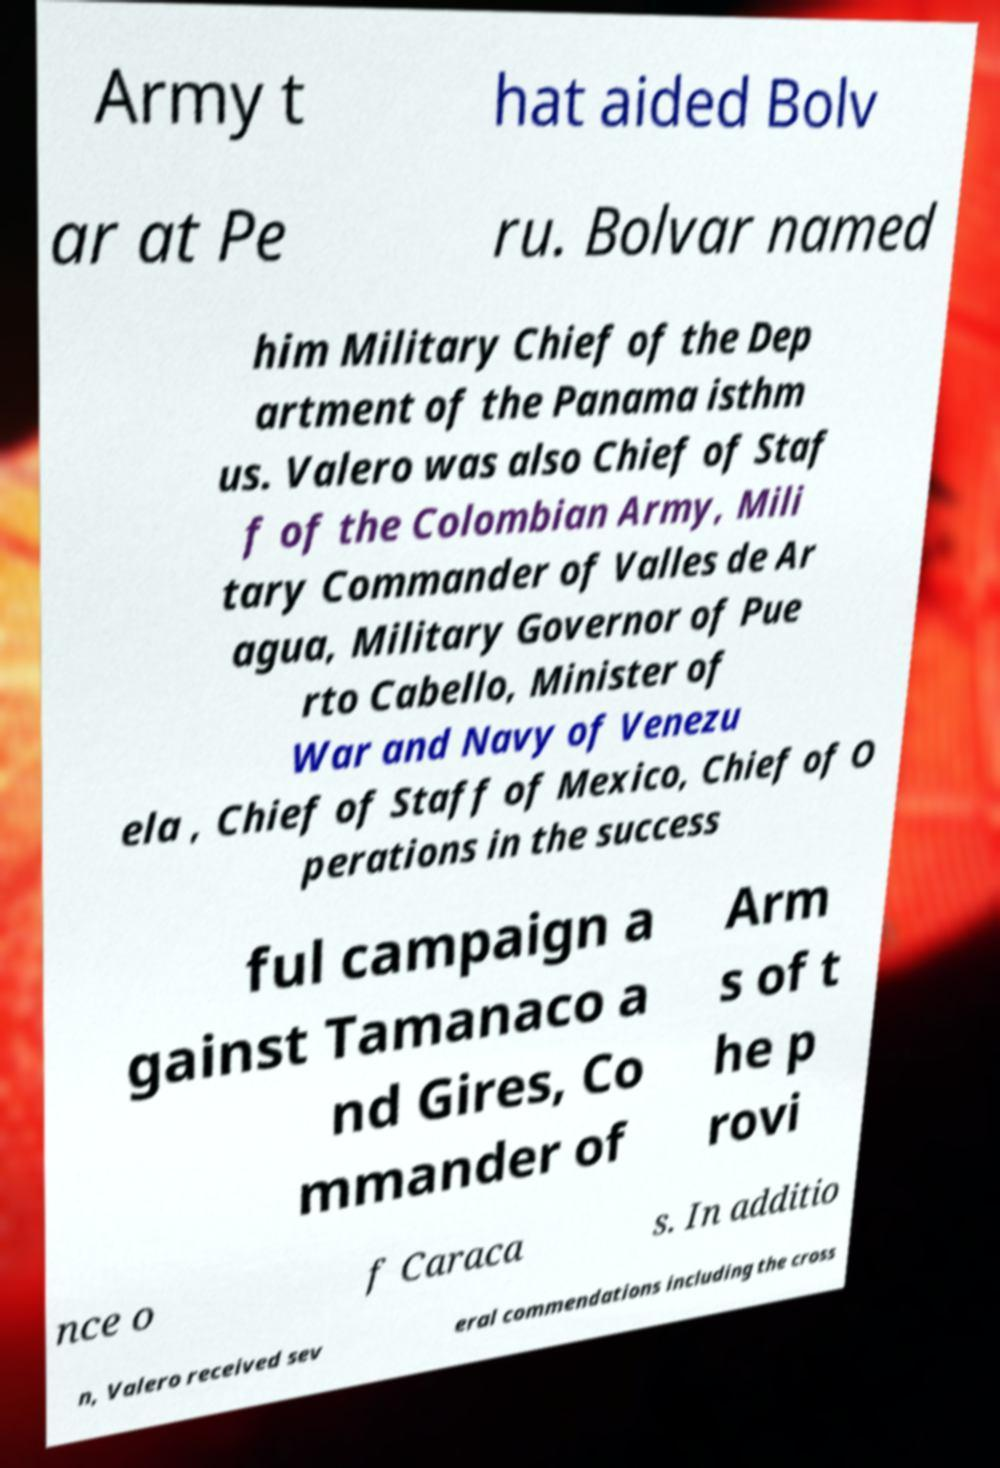There's text embedded in this image that I need extracted. Can you transcribe it verbatim? Army t hat aided Bolv ar at Pe ru. Bolvar named him Military Chief of the Dep artment of the Panama isthm us. Valero was also Chief of Staf f of the Colombian Army, Mili tary Commander of Valles de Ar agua, Military Governor of Pue rto Cabello, Minister of War and Navy of Venezu ela , Chief of Staff of Mexico, Chief of O perations in the success ful campaign a gainst Tamanaco a nd Gires, Co mmander of Arm s of t he p rovi nce o f Caraca s. In additio n, Valero received sev eral commendations including the cross 